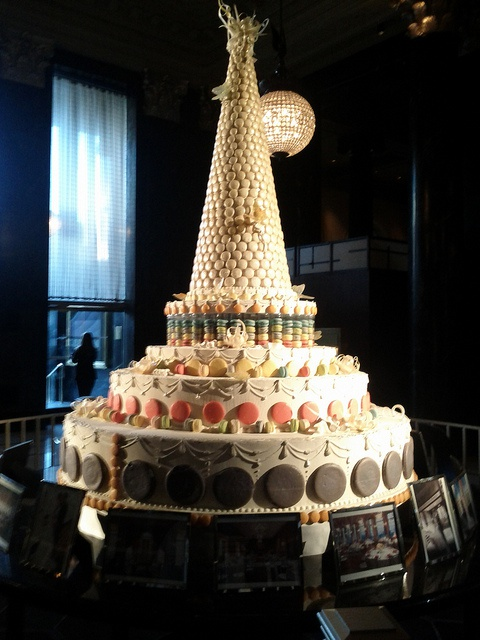Describe the objects in this image and their specific colors. I can see cake in black, beige, and tan tones and people in black, navy, blue, and teal tones in this image. 